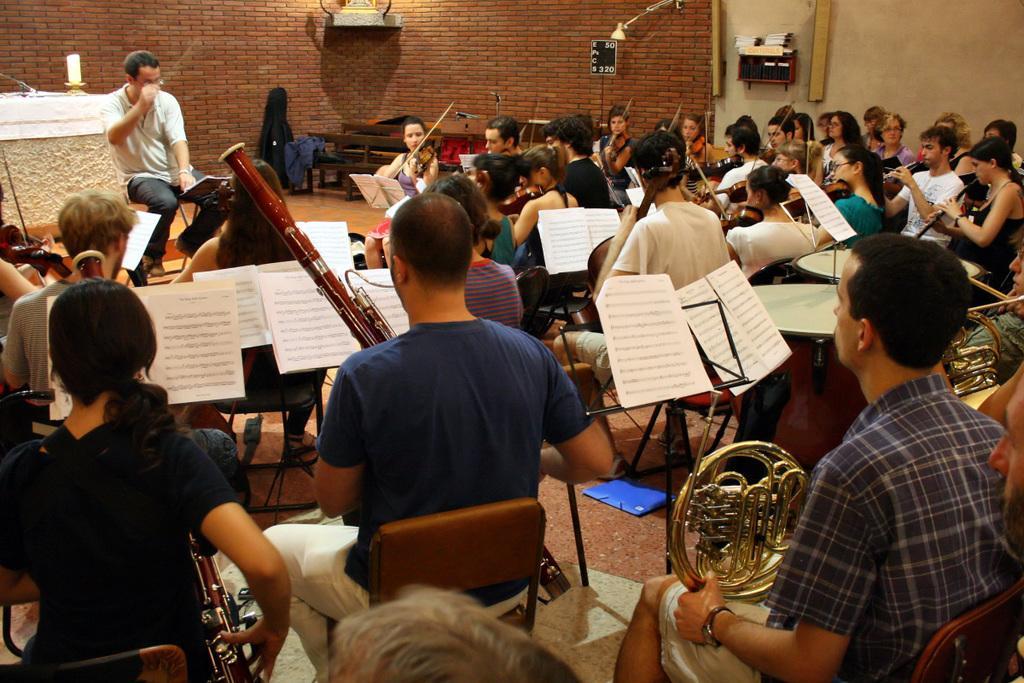How would you summarize this image in a sentence or two? In this picture I can see there are a few people sitting on the chairs and they are playing musical instruments, they have books in front of them and there is a book stand. Onto left side sitting at the left side and in the backdrop there is a wall. 